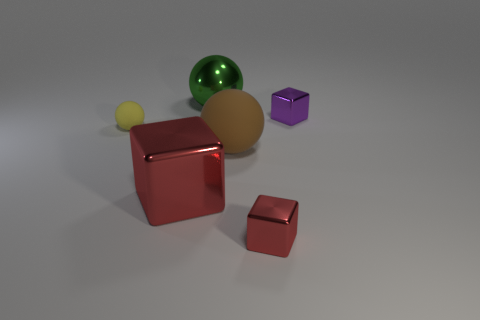How many red blocks must be subtracted to get 1 red blocks? 1 Add 4 large balls. How many objects exist? 10 Subtract all matte spheres. How many spheres are left? 1 Subtract all red blocks. How many blocks are left? 1 Subtract 1 cubes. How many cubes are left? 2 Subtract all green cubes. Subtract all yellow cylinders. How many cubes are left? 3 Subtract all red cubes. How many purple spheres are left? 0 Subtract all big matte balls. Subtract all green things. How many objects are left? 4 Add 4 purple cubes. How many purple cubes are left? 5 Add 3 large brown rubber spheres. How many large brown rubber spheres exist? 4 